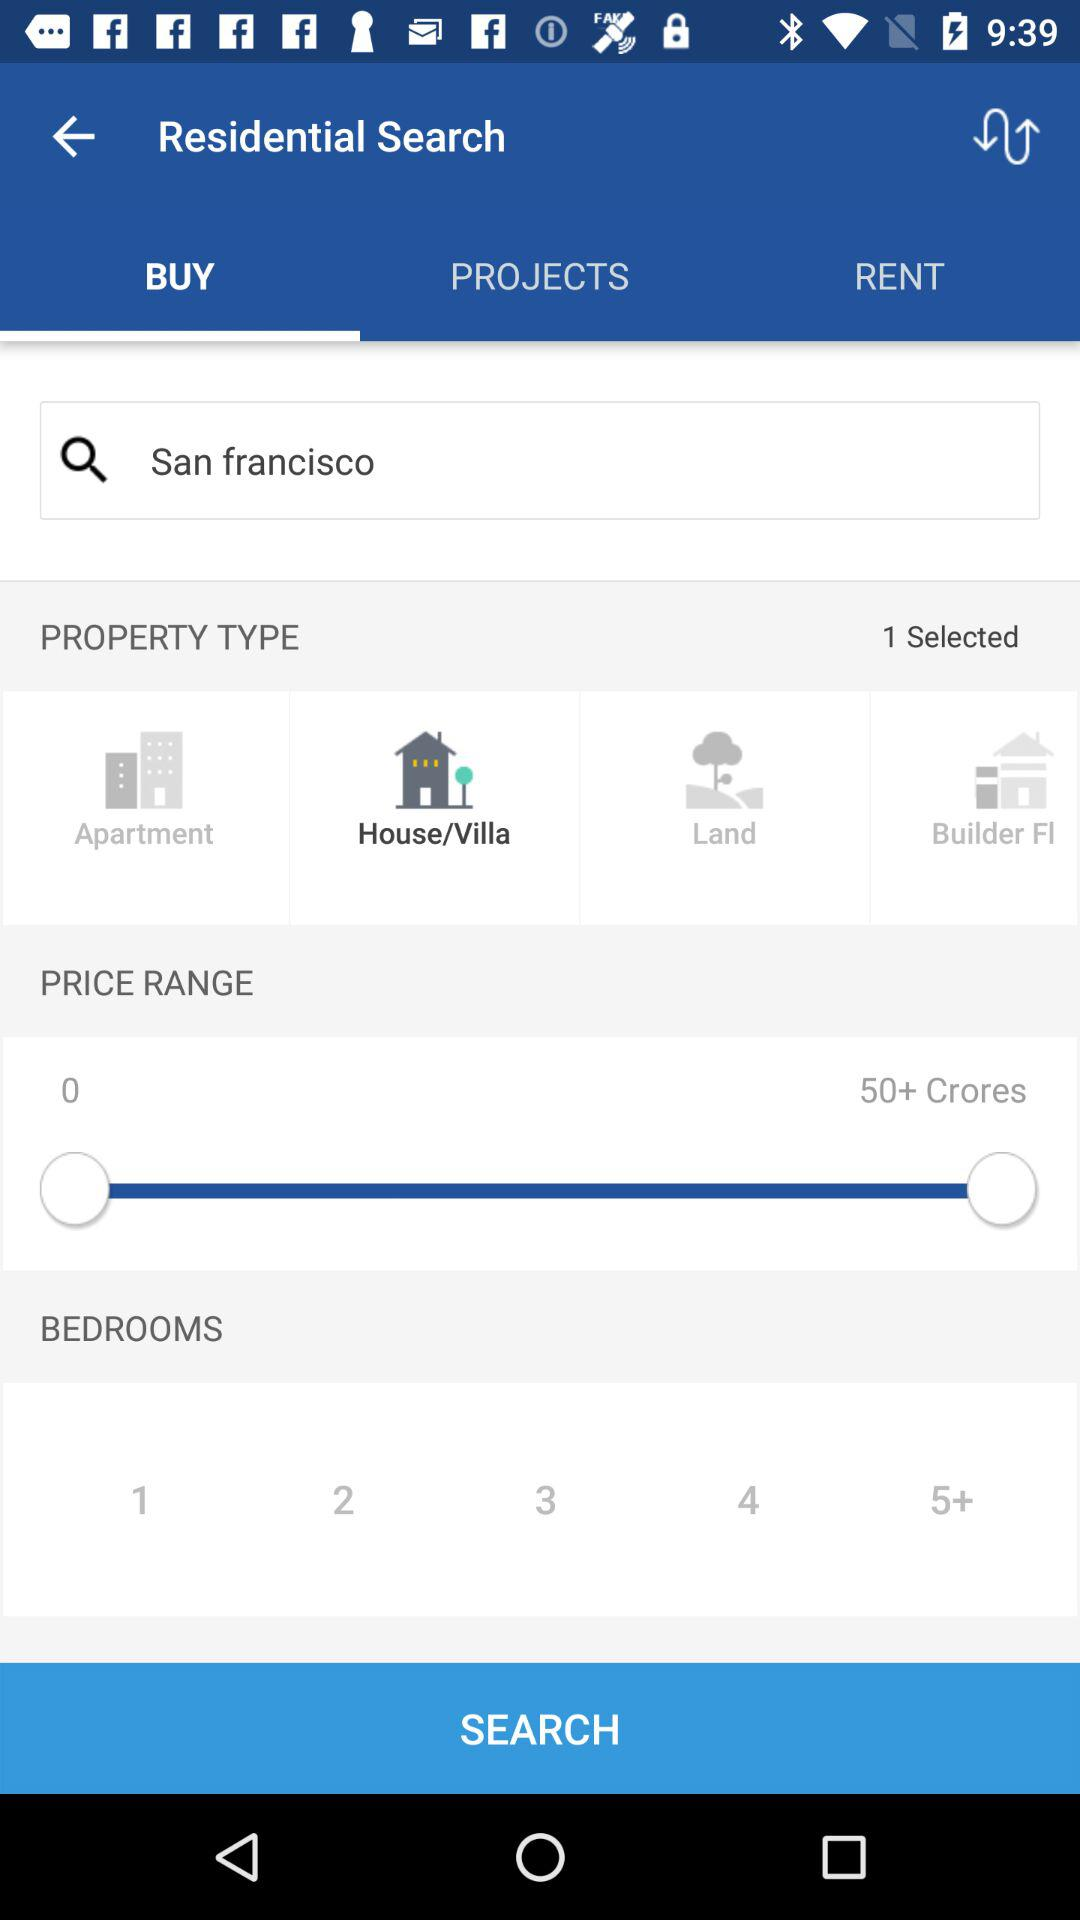Which is the selected tab? The selected tab is "BUY". 